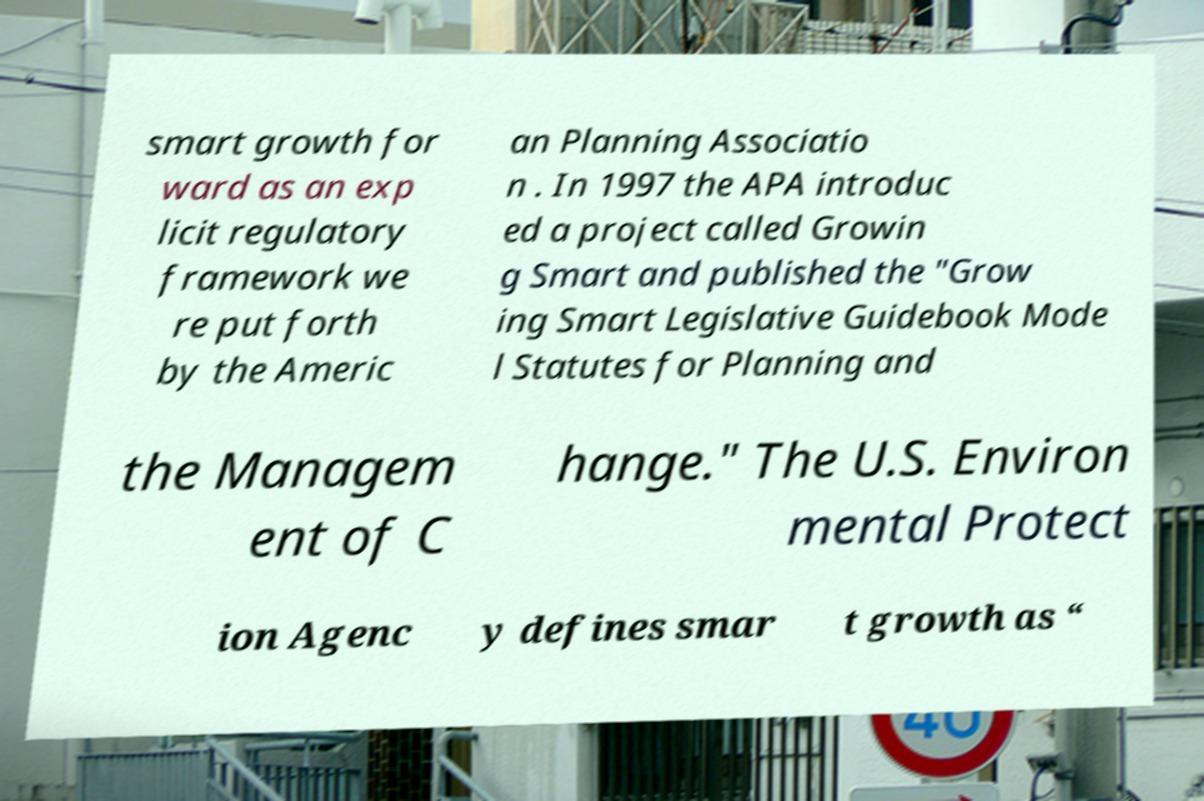Can you read and provide the text displayed in the image?This photo seems to have some interesting text. Can you extract and type it out for me? smart growth for ward as an exp licit regulatory framework we re put forth by the Americ an Planning Associatio n . In 1997 the APA introduc ed a project called Growin g Smart and published the "Grow ing Smart Legislative Guidebook Mode l Statutes for Planning and the Managem ent of C hange." The U.S. Environ mental Protect ion Agenc y defines smar t growth as “ 